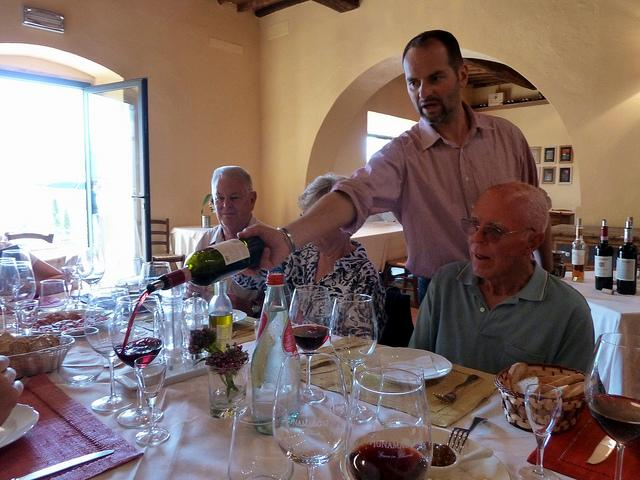From which fruit does the beverage served here come?

Choices:
A) banana
B) melon
C) grape
D) kiwi grape 